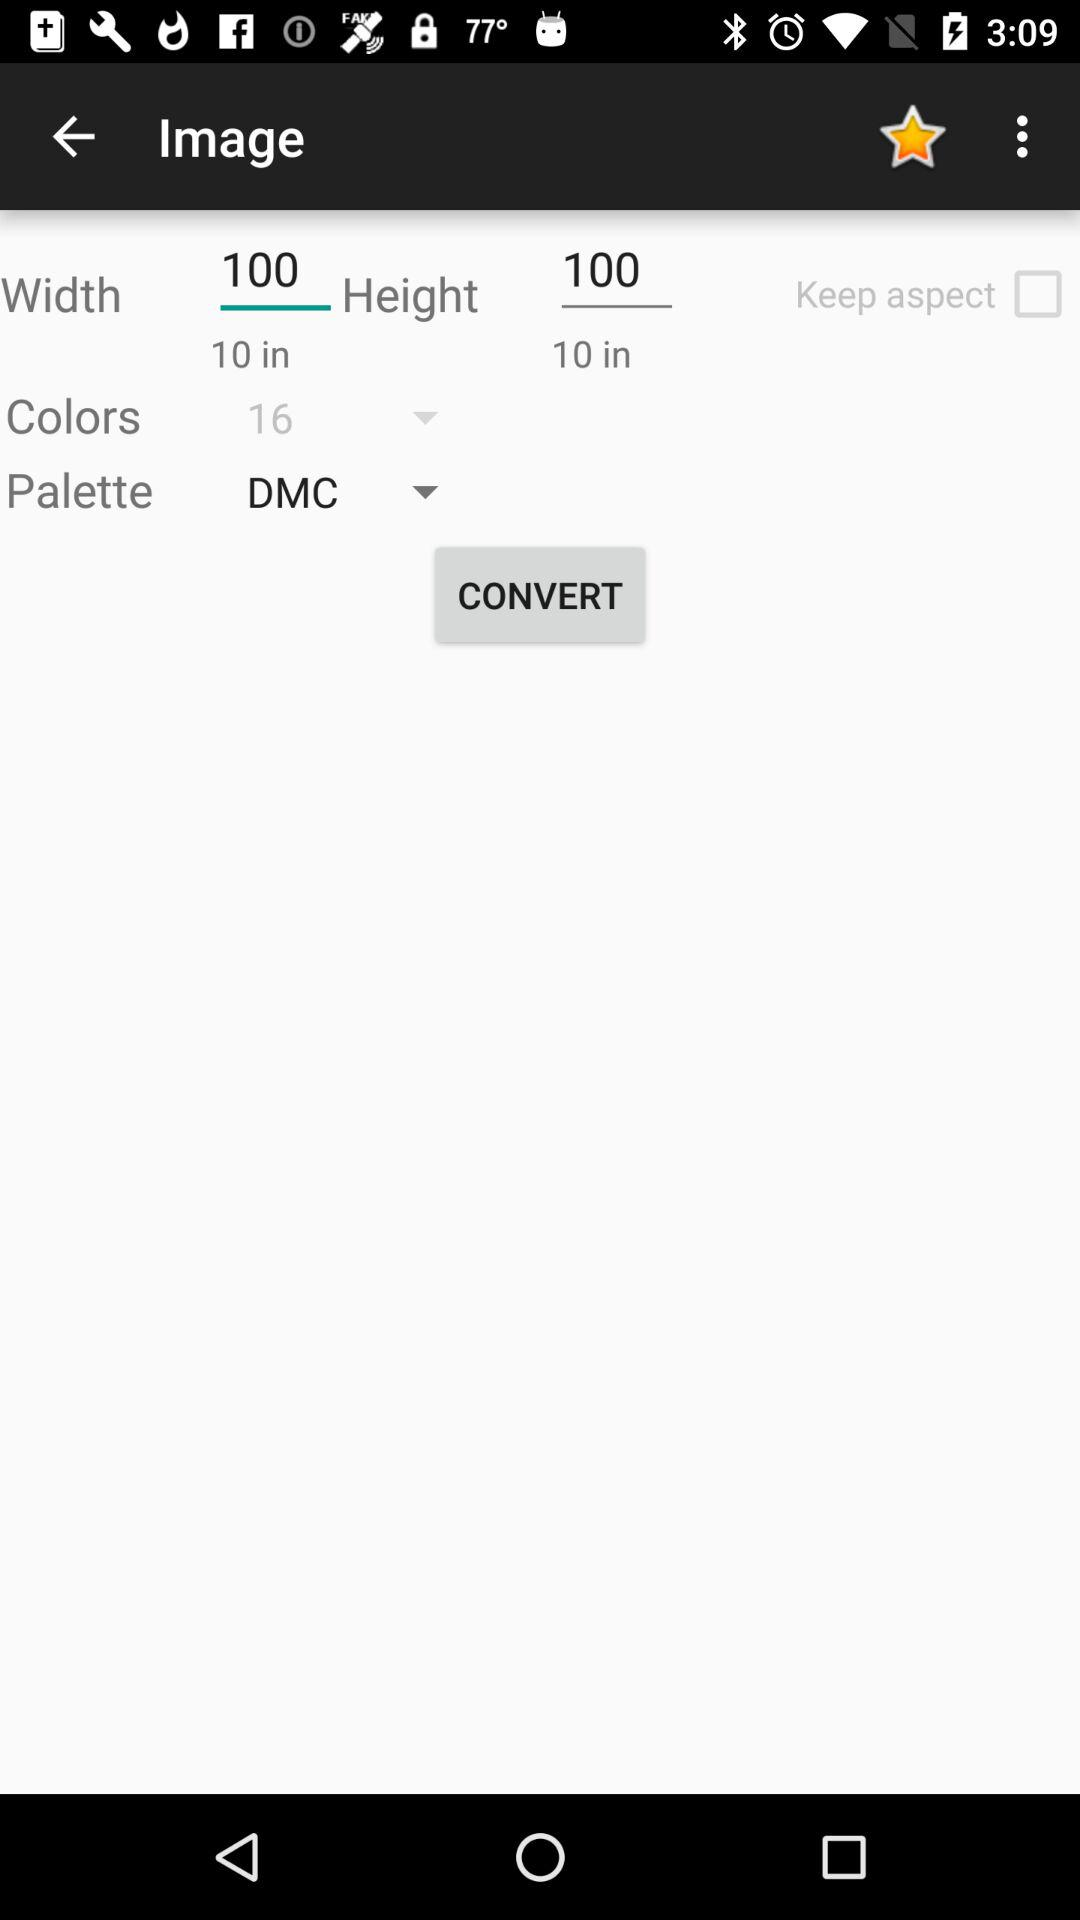What is the entered width? The entered width is 100. 